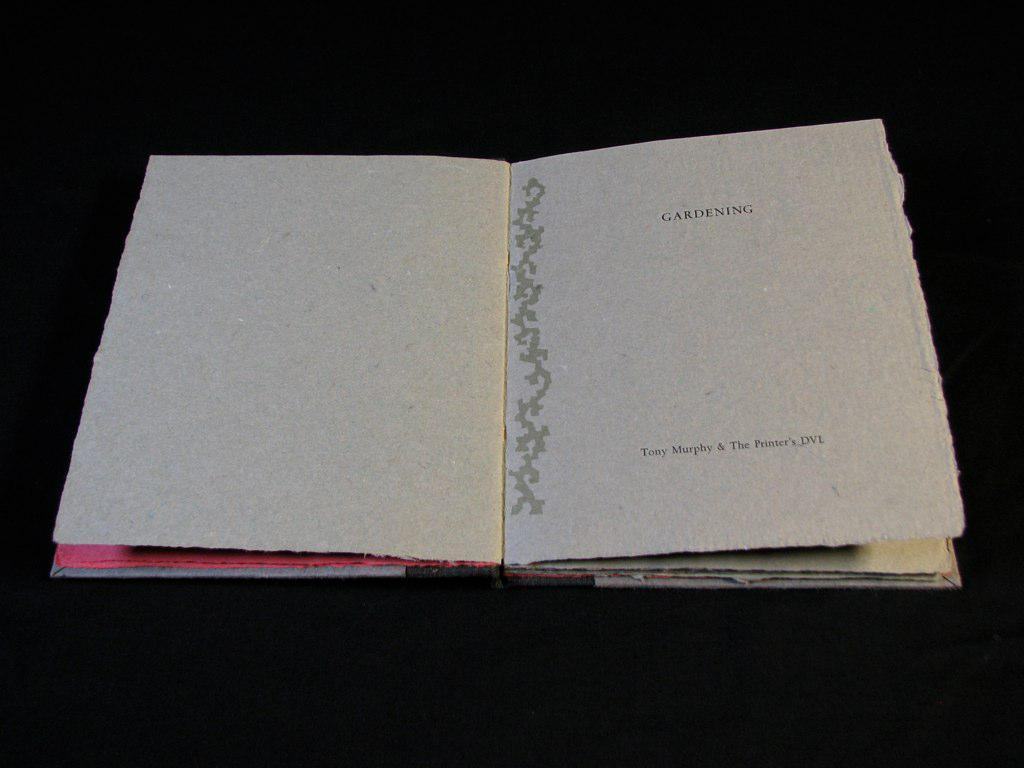<image>
Present a compact description of the photo's key features. A book is opened to a page titled gardening. 